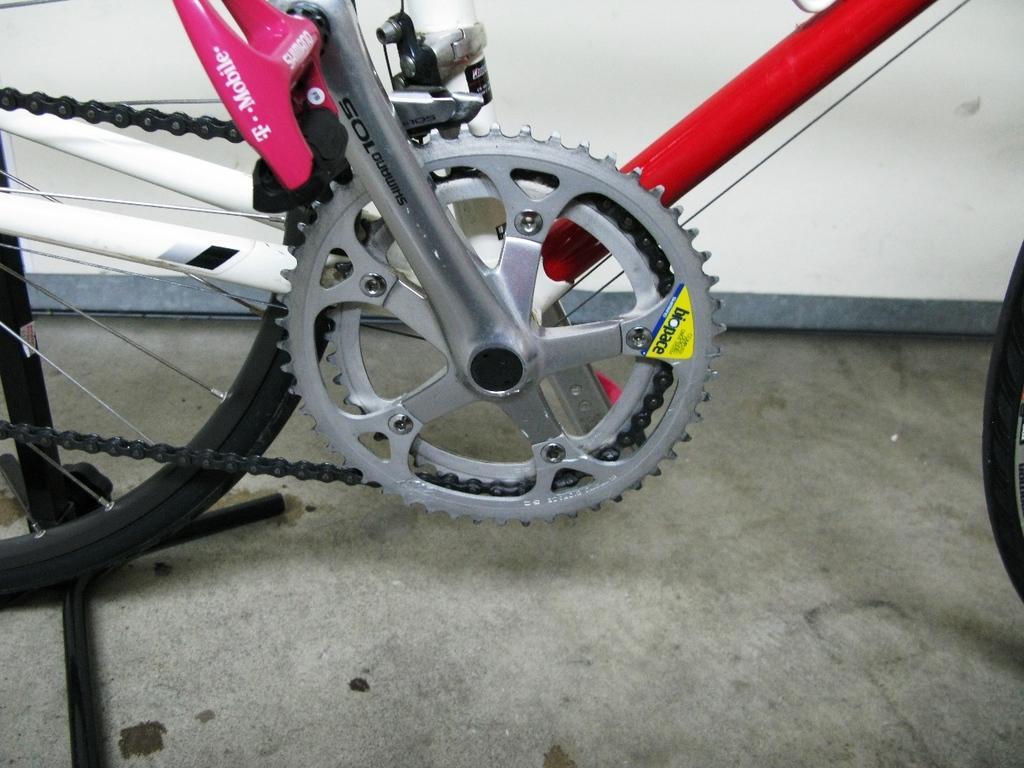Please provide a concise description of this image. In this image, this looks like a bicycle with a chain ring, wheel, spokes and few other things attached to it. This is the wall. 